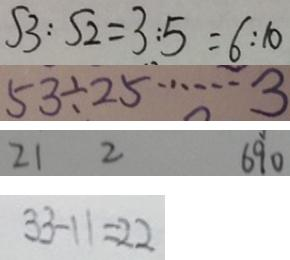<formula> <loc_0><loc_0><loc_500><loc_500>S 3 : S 2 = 3 : 5 = 6 : 1 0 
 5 3 \div 2 5 \cdots 3 
 2 1 2 6 9 0 
 3 3 - 1 1 = 2 2</formula> 